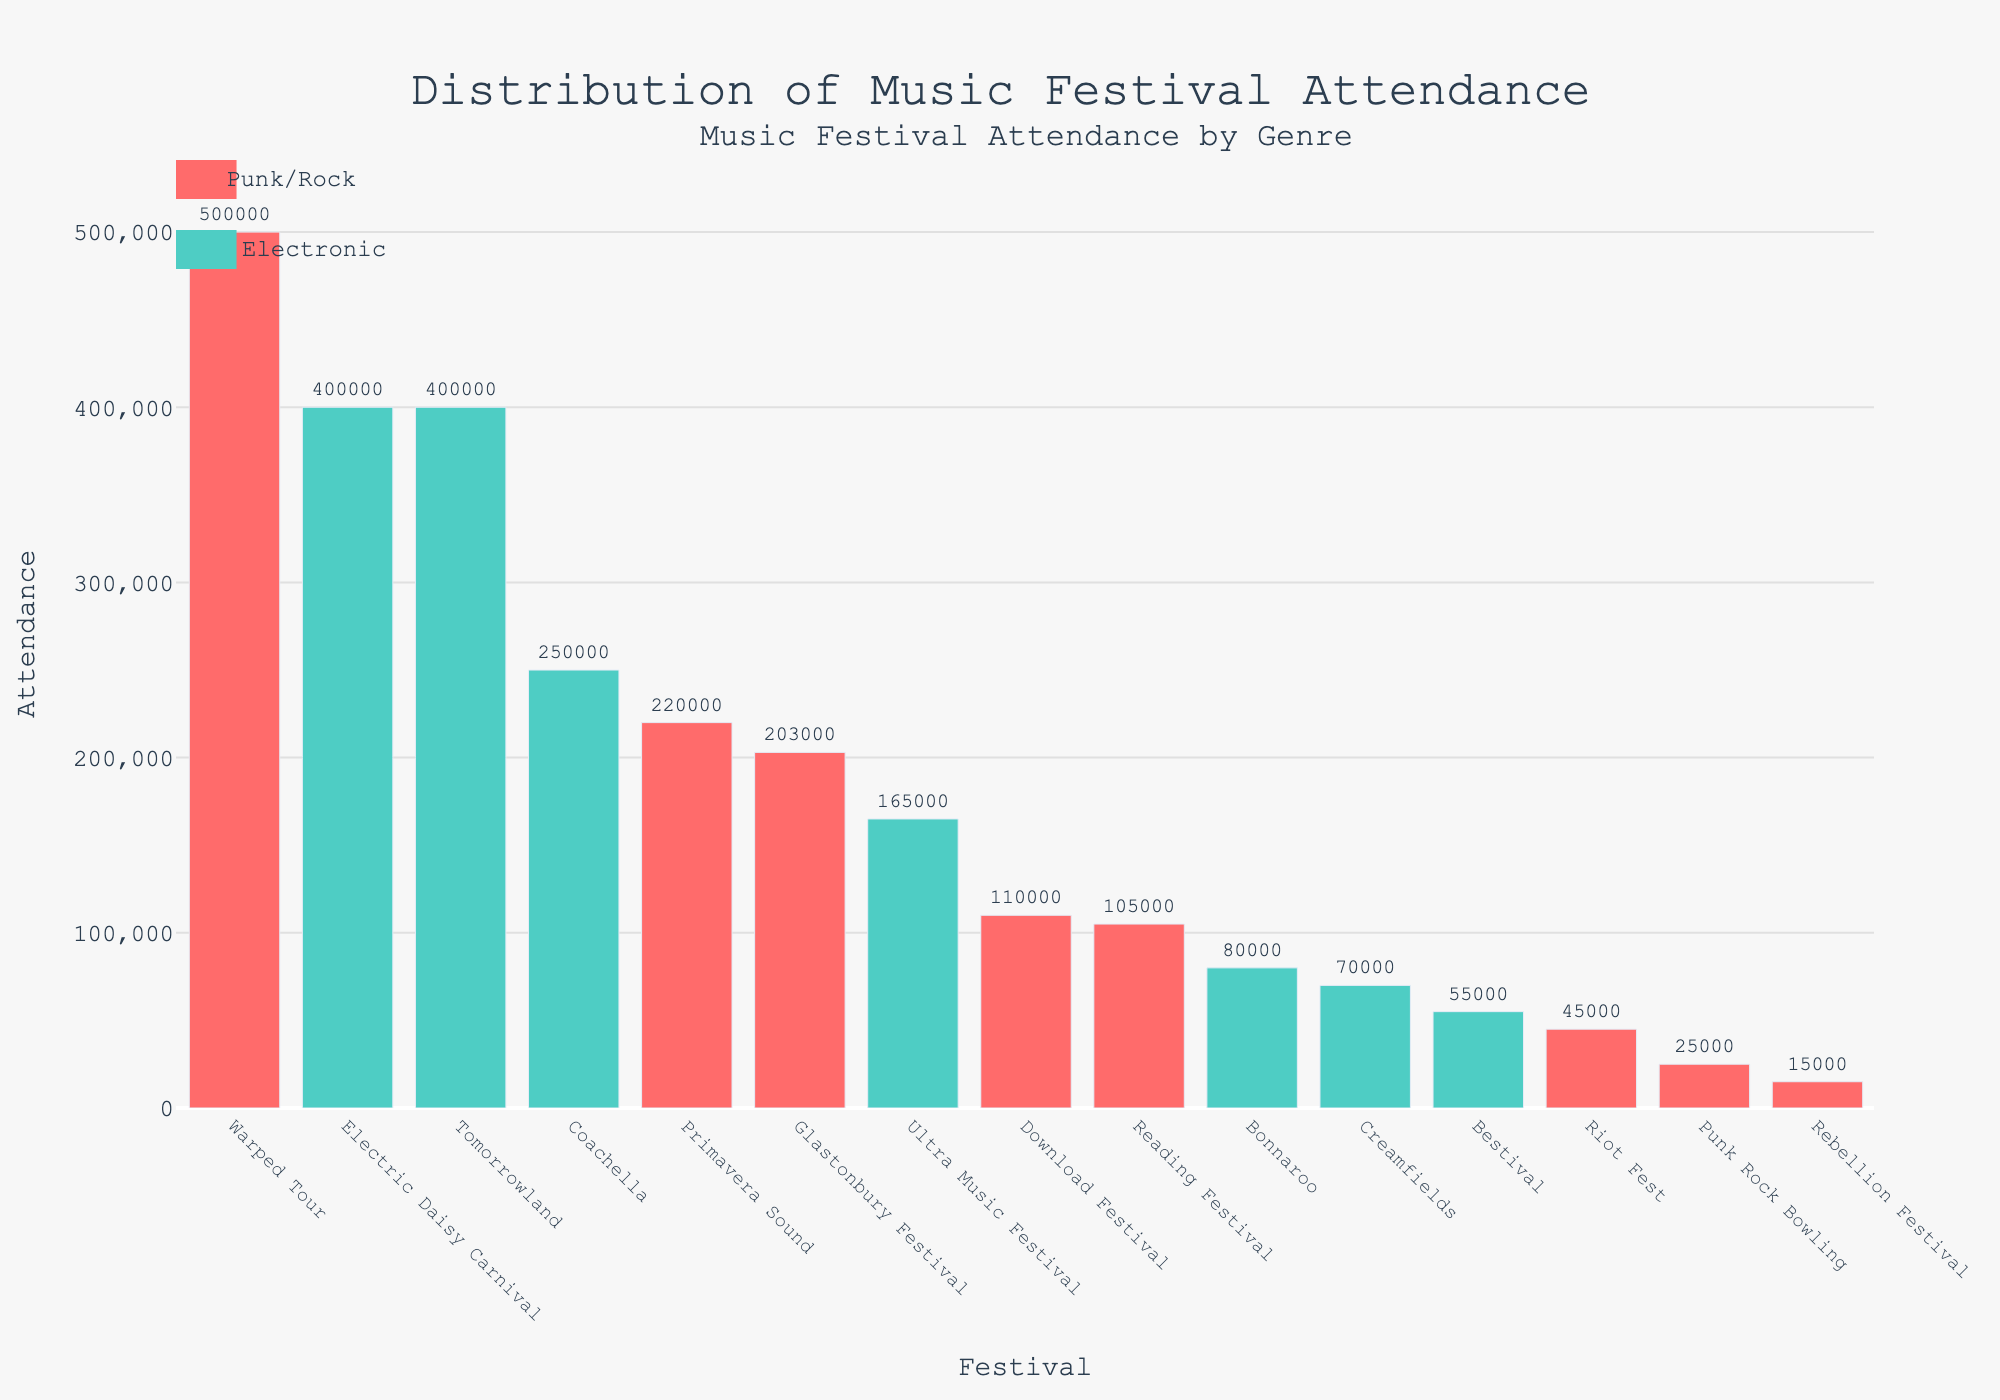Which festival has the highest attendance? The highest bar represents the festival with the highest attendance. The "Warped Tour" bar is the tallest, indicating the highest attendance.
Answer: Warped Tour Which genre has the most festivals with attendance over 100,000? Count the number of festivals for each genre with attendance over 100,000. Punk has three (Download Festival, Warped Tour, Reading Festival), while Electronic has three (Ultra Music Festival, Electric Daisy Carnival, Tomorrowland).
Answer: Punk and Electronic What is the total attendance for all punk festivals? Add the attendance numbers from all punk festivals: Download Festival (110,000), Rebellion Festival (15,000), Warped Tour (500,000), Punk Rock Bowling (25,000), Riot Fest (45,000). The total is 110,000 + 15,000 + 500,000 + 25,000 + 45,000 = 695,000.
Answer: 695,000 How does the attendance at Tomorrowland compare to that at Primavera Sound? Compare the heights of the bars for Tomorrowland and Primavera Sound. Tomorrowland's attendance (400,000) is higher than Primavera Sound's (220,000).
Answer: Tomorrowland is higher Which genre has the highest single festival attendance? Identify the highest attendance in the plot and check its genre. Warped Tour has the highest attendance at 500,000, and its genre is Punk/Alternative.
Answer: Punk/Alternative What is the average attendance of electronic festivals? Add the attendance for all electronic festivals and divide by the number of festivals: (165,000 + 400,000 + 400,000 + 70,000 + 55,000 + 250,000)/6. The total is 1,340,000, so the average is 1,340,000 /6 = 223,333.33.
Answer: 223,333.33 How many festivals have attendance between 50,000 and 200,000? Count the festivals with attendance in the range 50,000-200,000. They are Rebellion Festival, Punk Rock Bowling, Riot Fest, Creamfields, Bestival, Download Festival, Reading Festival, and Bonnaroo; a total of 8.
Answer: 8 